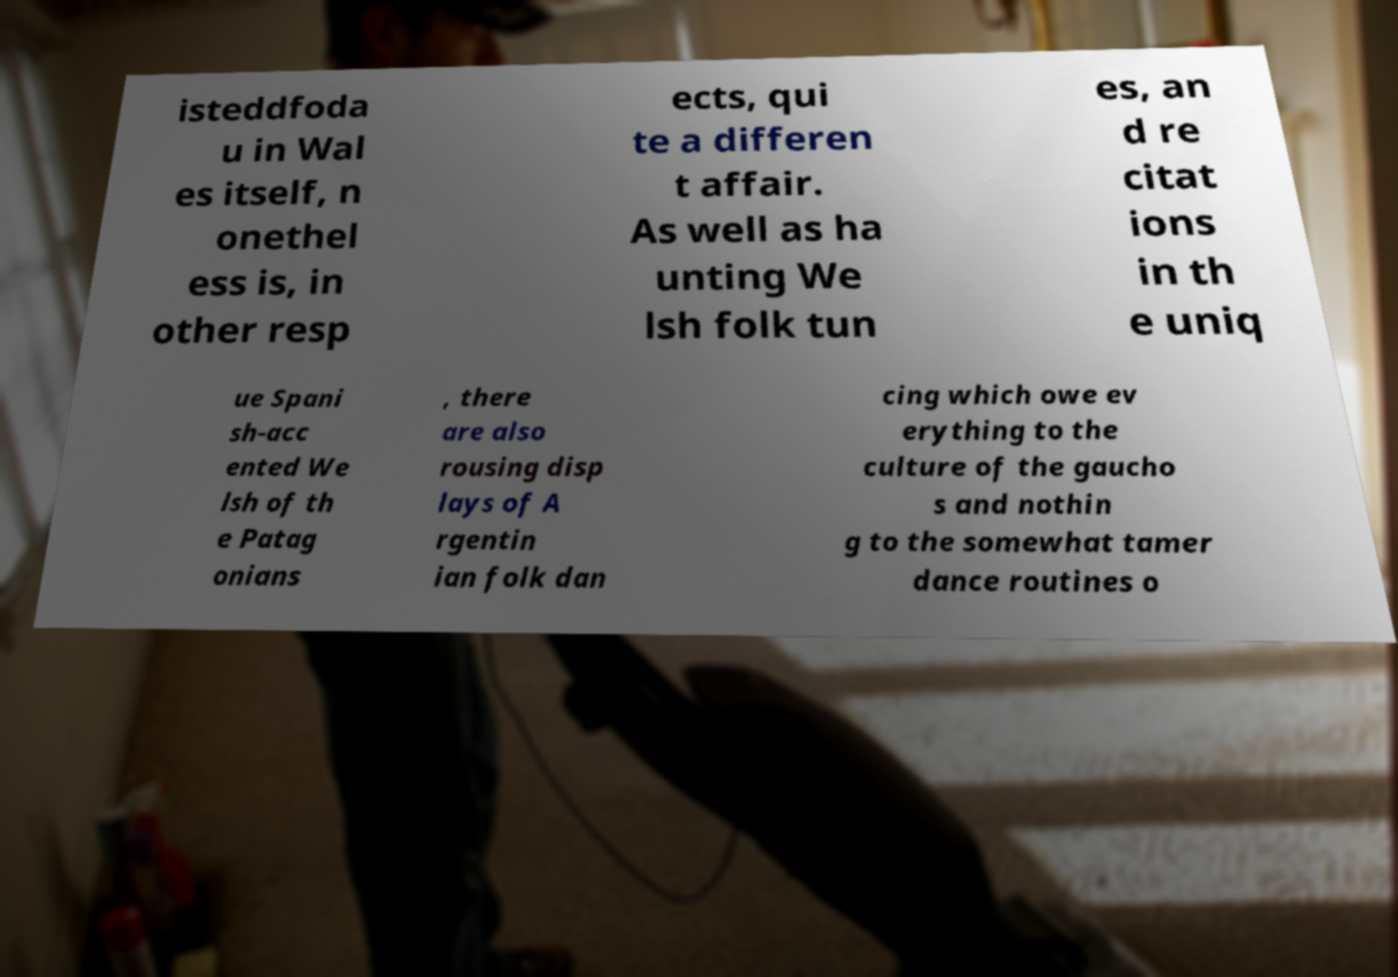I need the written content from this picture converted into text. Can you do that? isteddfoda u in Wal es itself, n onethel ess is, in other resp ects, qui te a differen t affair. As well as ha unting We lsh folk tun es, an d re citat ions in th e uniq ue Spani sh-acc ented We lsh of th e Patag onians , there are also rousing disp lays of A rgentin ian folk dan cing which owe ev erything to the culture of the gaucho s and nothin g to the somewhat tamer dance routines o 